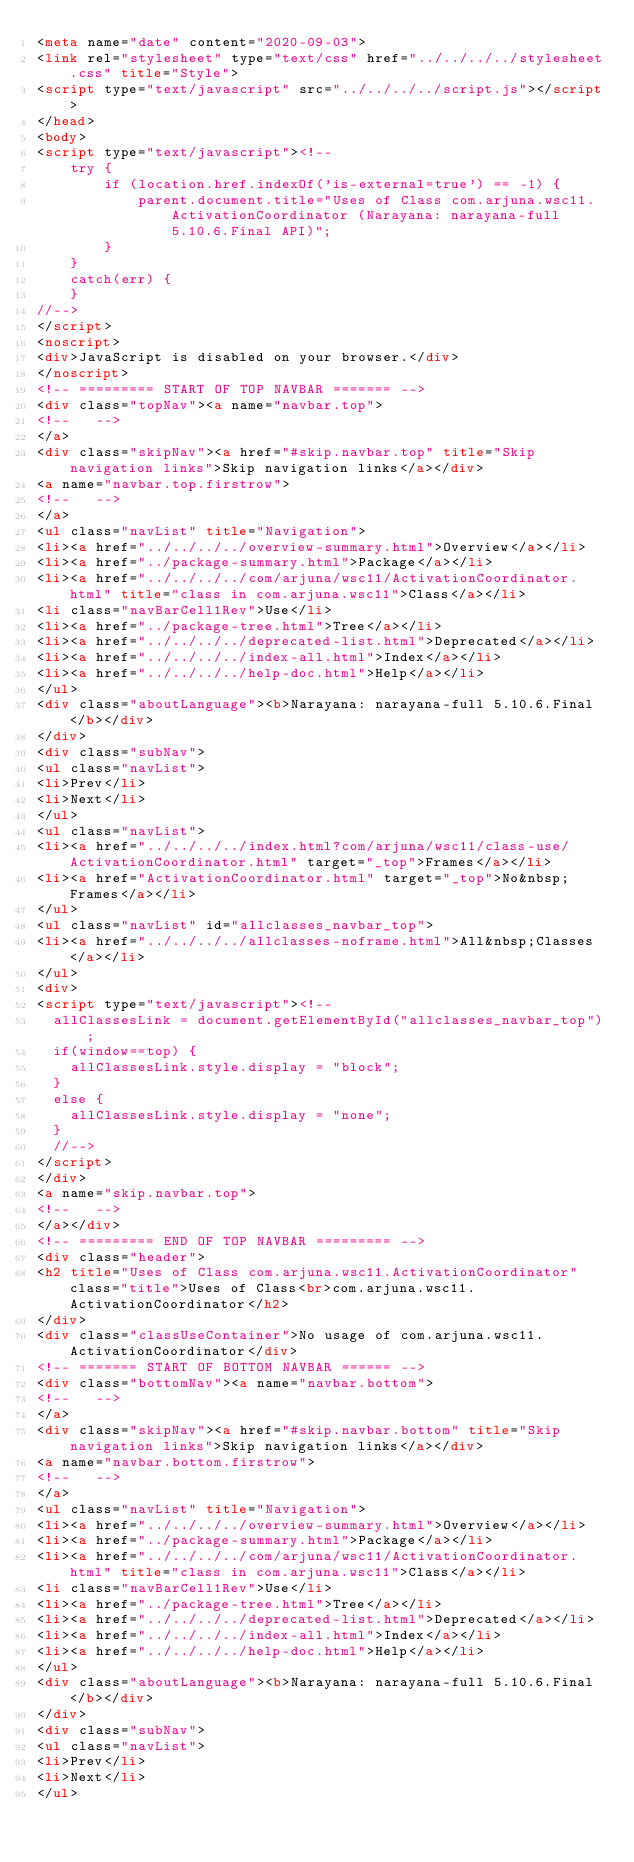Convert code to text. <code><loc_0><loc_0><loc_500><loc_500><_HTML_><meta name="date" content="2020-09-03">
<link rel="stylesheet" type="text/css" href="../../../../stylesheet.css" title="Style">
<script type="text/javascript" src="../../../../script.js"></script>
</head>
<body>
<script type="text/javascript"><!--
    try {
        if (location.href.indexOf('is-external=true') == -1) {
            parent.document.title="Uses of Class com.arjuna.wsc11.ActivationCoordinator (Narayana: narayana-full 5.10.6.Final API)";
        }
    }
    catch(err) {
    }
//-->
</script>
<noscript>
<div>JavaScript is disabled on your browser.</div>
</noscript>
<!-- ========= START OF TOP NAVBAR ======= -->
<div class="topNav"><a name="navbar.top">
<!--   -->
</a>
<div class="skipNav"><a href="#skip.navbar.top" title="Skip navigation links">Skip navigation links</a></div>
<a name="navbar.top.firstrow">
<!--   -->
</a>
<ul class="navList" title="Navigation">
<li><a href="../../../../overview-summary.html">Overview</a></li>
<li><a href="../package-summary.html">Package</a></li>
<li><a href="../../../../com/arjuna/wsc11/ActivationCoordinator.html" title="class in com.arjuna.wsc11">Class</a></li>
<li class="navBarCell1Rev">Use</li>
<li><a href="../package-tree.html">Tree</a></li>
<li><a href="../../../../deprecated-list.html">Deprecated</a></li>
<li><a href="../../../../index-all.html">Index</a></li>
<li><a href="../../../../help-doc.html">Help</a></li>
</ul>
<div class="aboutLanguage"><b>Narayana: narayana-full 5.10.6.Final</b></div>
</div>
<div class="subNav">
<ul class="navList">
<li>Prev</li>
<li>Next</li>
</ul>
<ul class="navList">
<li><a href="../../../../index.html?com/arjuna/wsc11/class-use/ActivationCoordinator.html" target="_top">Frames</a></li>
<li><a href="ActivationCoordinator.html" target="_top">No&nbsp;Frames</a></li>
</ul>
<ul class="navList" id="allclasses_navbar_top">
<li><a href="../../../../allclasses-noframe.html">All&nbsp;Classes</a></li>
</ul>
<div>
<script type="text/javascript"><!--
  allClassesLink = document.getElementById("allclasses_navbar_top");
  if(window==top) {
    allClassesLink.style.display = "block";
  }
  else {
    allClassesLink.style.display = "none";
  }
  //-->
</script>
</div>
<a name="skip.navbar.top">
<!--   -->
</a></div>
<!-- ========= END OF TOP NAVBAR ========= -->
<div class="header">
<h2 title="Uses of Class com.arjuna.wsc11.ActivationCoordinator" class="title">Uses of Class<br>com.arjuna.wsc11.ActivationCoordinator</h2>
</div>
<div class="classUseContainer">No usage of com.arjuna.wsc11.ActivationCoordinator</div>
<!-- ======= START OF BOTTOM NAVBAR ====== -->
<div class="bottomNav"><a name="navbar.bottom">
<!--   -->
</a>
<div class="skipNav"><a href="#skip.navbar.bottom" title="Skip navigation links">Skip navigation links</a></div>
<a name="navbar.bottom.firstrow">
<!--   -->
</a>
<ul class="navList" title="Navigation">
<li><a href="../../../../overview-summary.html">Overview</a></li>
<li><a href="../package-summary.html">Package</a></li>
<li><a href="../../../../com/arjuna/wsc11/ActivationCoordinator.html" title="class in com.arjuna.wsc11">Class</a></li>
<li class="navBarCell1Rev">Use</li>
<li><a href="../package-tree.html">Tree</a></li>
<li><a href="../../../../deprecated-list.html">Deprecated</a></li>
<li><a href="../../../../index-all.html">Index</a></li>
<li><a href="../../../../help-doc.html">Help</a></li>
</ul>
<div class="aboutLanguage"><b>Narayana: narayana-full 5.10.6.Final</b></div>
</div>
<div class="subNav">
<ul class="navList">
<li>Prev</li>
<li>Next</li>
</ul></code> 